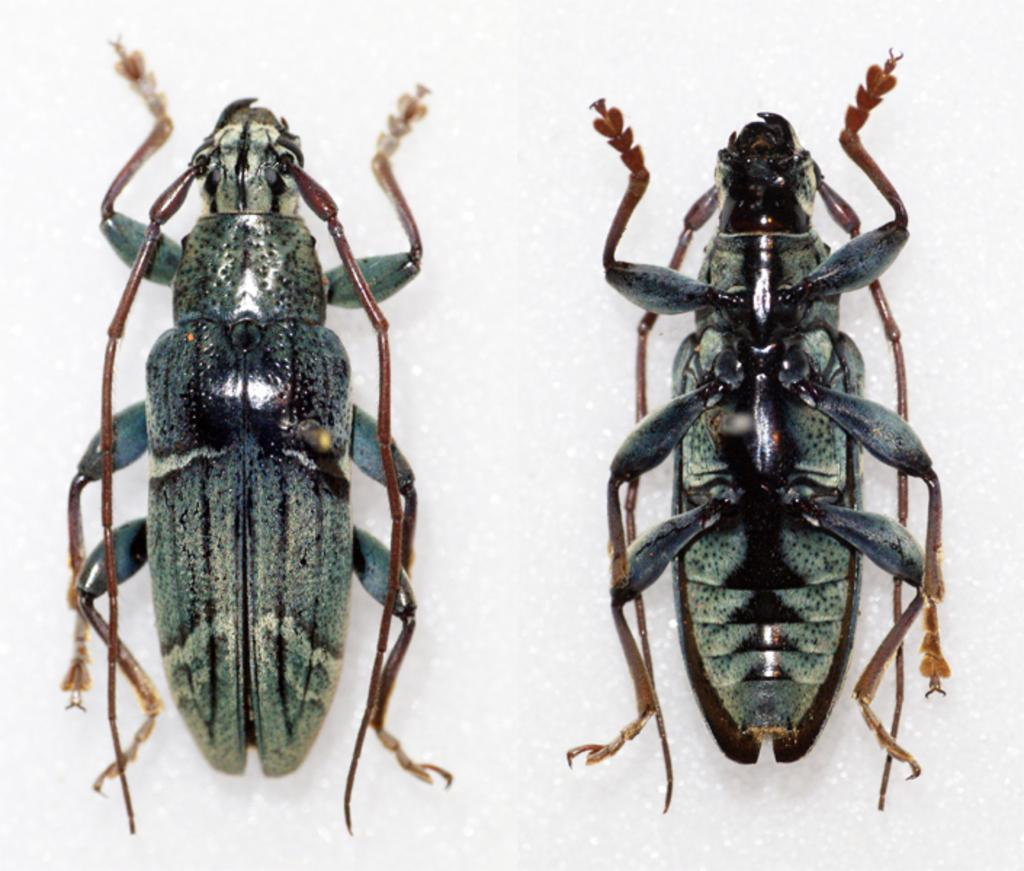How many insects are present in the image? There are two insects in the image. What can be seen in the background of the image? The background of the image is white. What type of care system is in place for the mother in the image? There is no mother or care system present in the image; it only features two insects against a white background. 